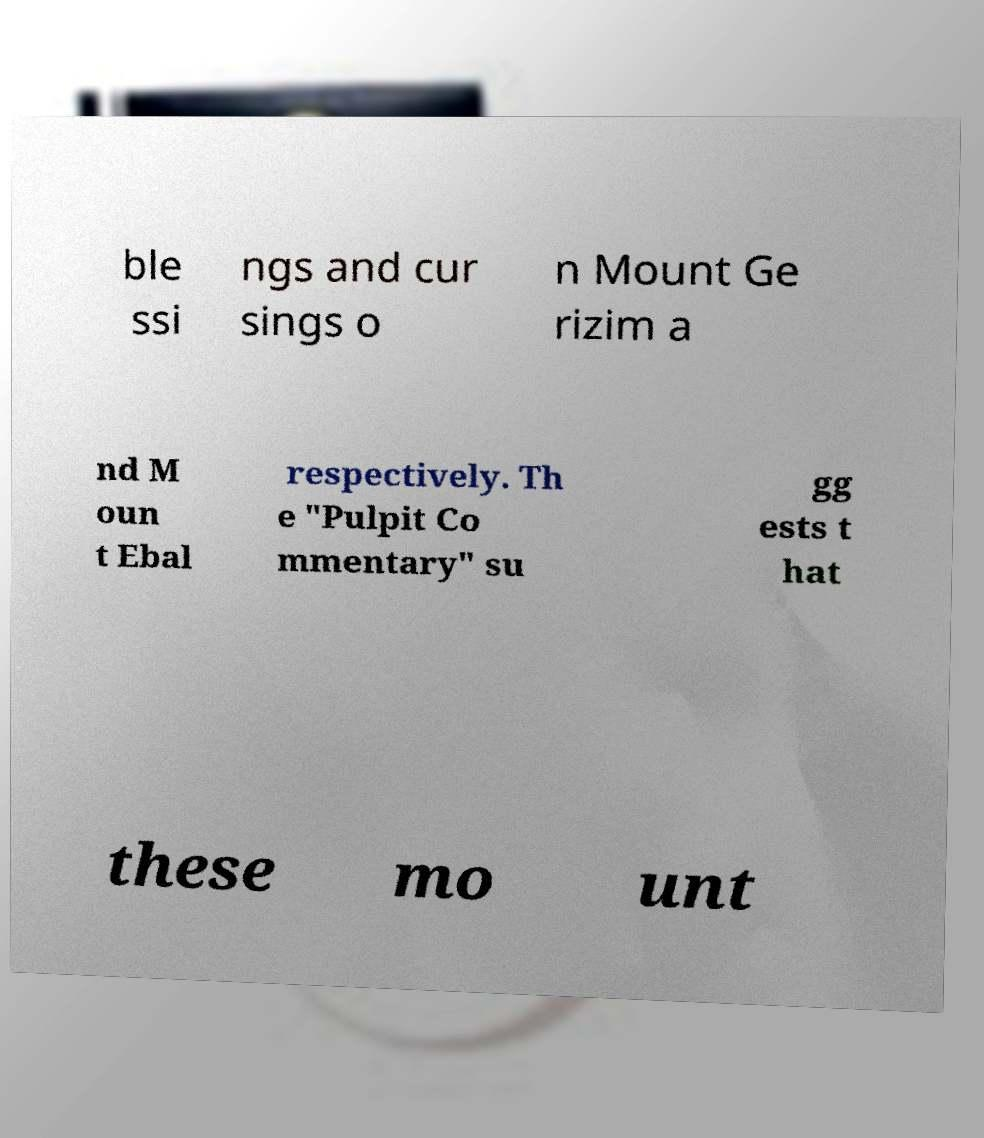For documentation purposes, I need the text within this image transcribed. Could you provide that? ble ssi ngs and cur sings o n Mount Ge rizim a nd M oun t Ebal respectively. Th e "Pulpit Co mmentary" su gg ests t hat these mo unt 